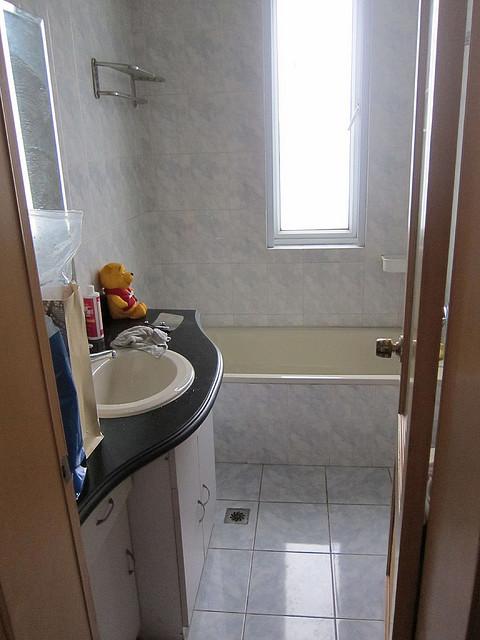Is there a real bear sitting next to the sink?
Answer briefly. No. Where is the light coming from?
Answer briefly. Window. What kind of room is this?
Write a very short answer. Bathroom. 